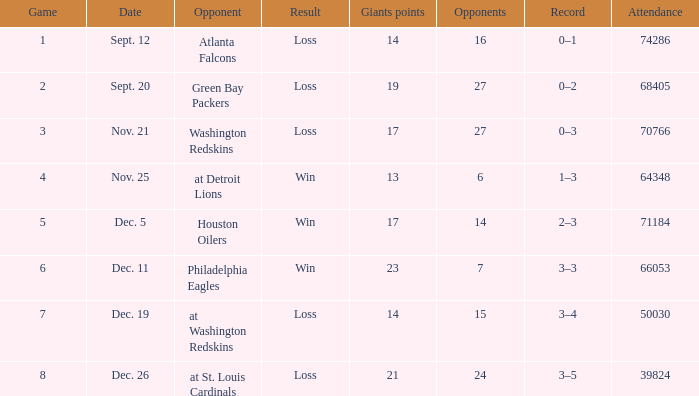What is the minimum number of opponents? 6.0. 